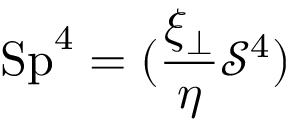<formula> <loc_0><loc_0><loc_500><loc_500>S p ^ { 4 } = ( \frac { \xi _ { \perp } } { \eta } \mathcal { S } ^ { 4 } )</formula> 